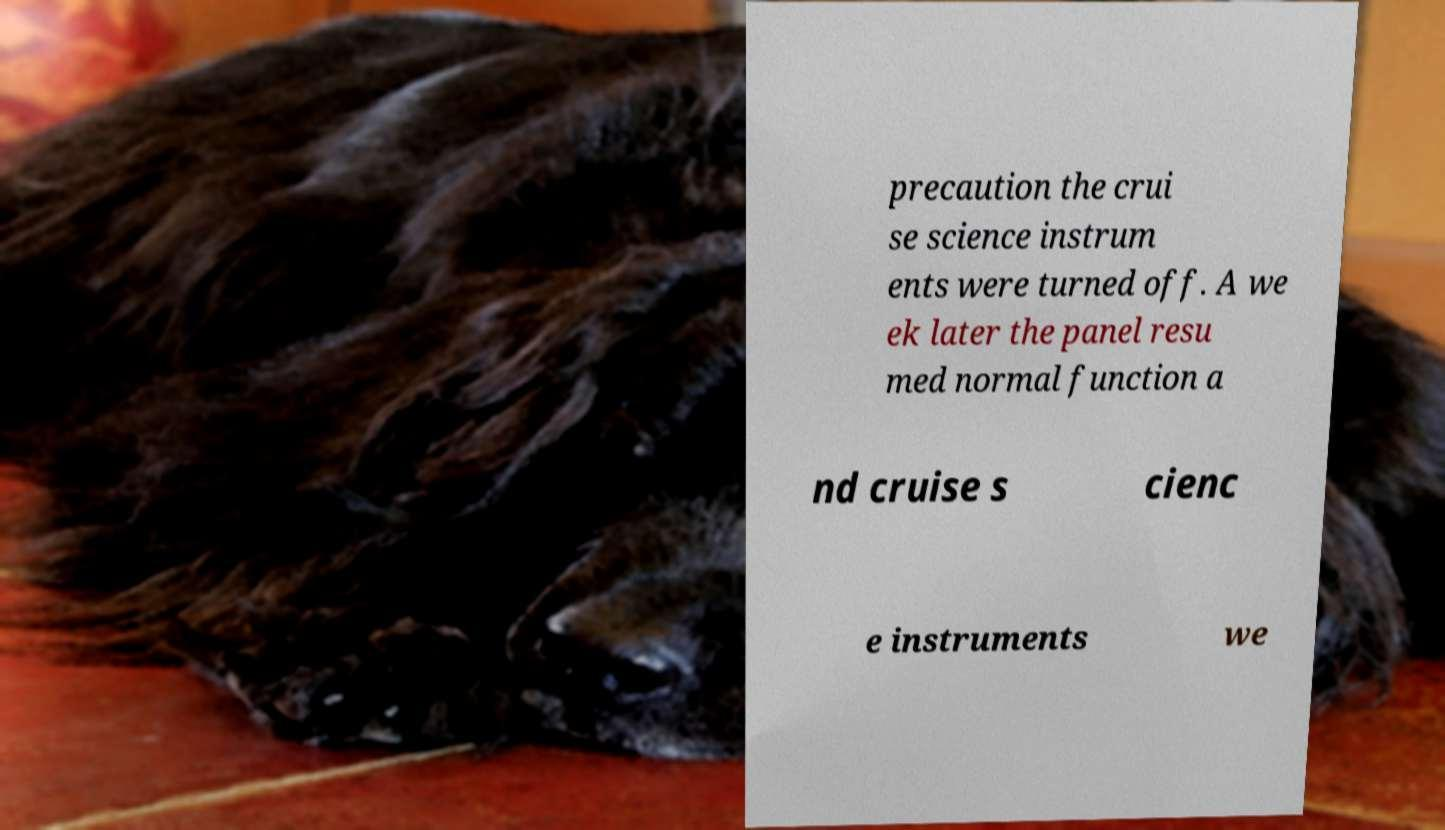There's text embedded in this image that I need extracted. Can you transcribe it verbatim? precaution the crui se science instrum ents were turned off. A we ek later the panel resu med normal function a nd cruise s cienc e instruments we 